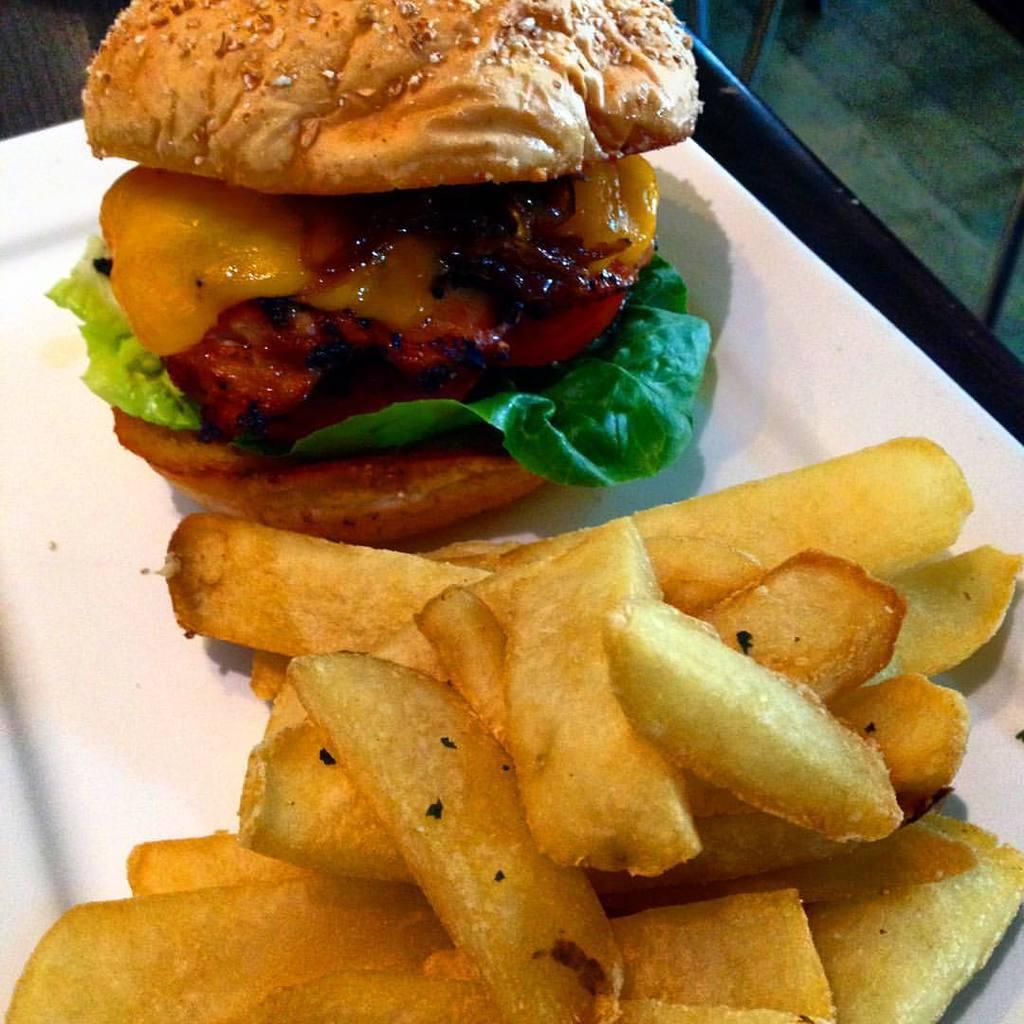Can you describe this image briefly? In this image I can see a plate in which french fries and a bread sandwich is there kept on the table. This image is taken may be in a hotel. 